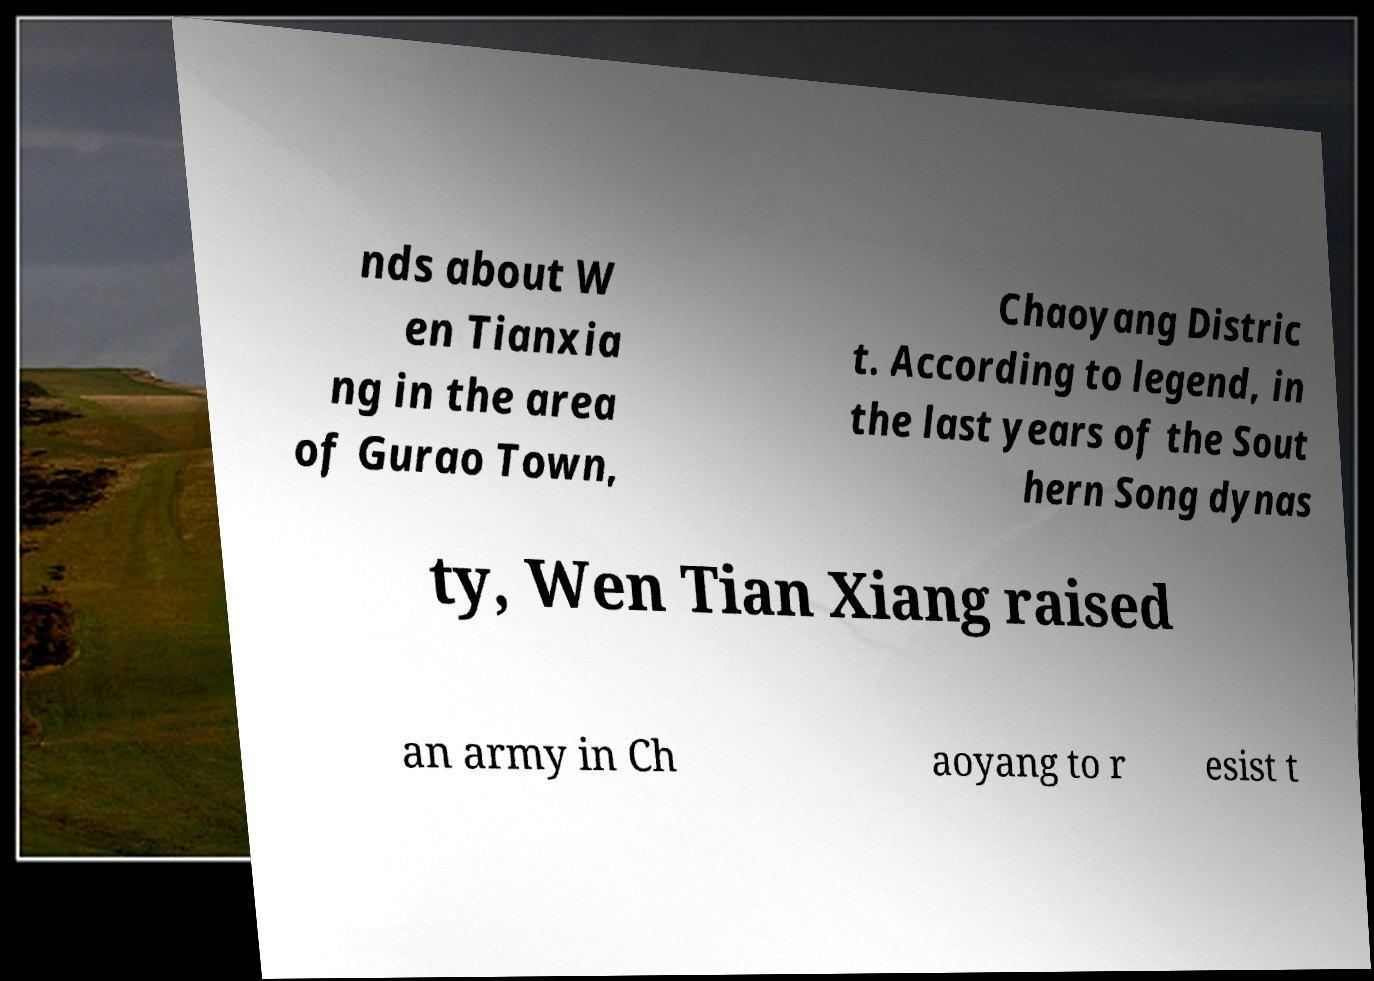There's text embedded in this image that I need extracted. Can you transcribe it verbatim? nds about W en Tianxia ng in the area of Gurao Town, Chaoyang Distric t. According to legend, in the last years of the Sout hern Song dynas ty, Wen Tian Xiang raised an army in Ch aoyang to r esist t 